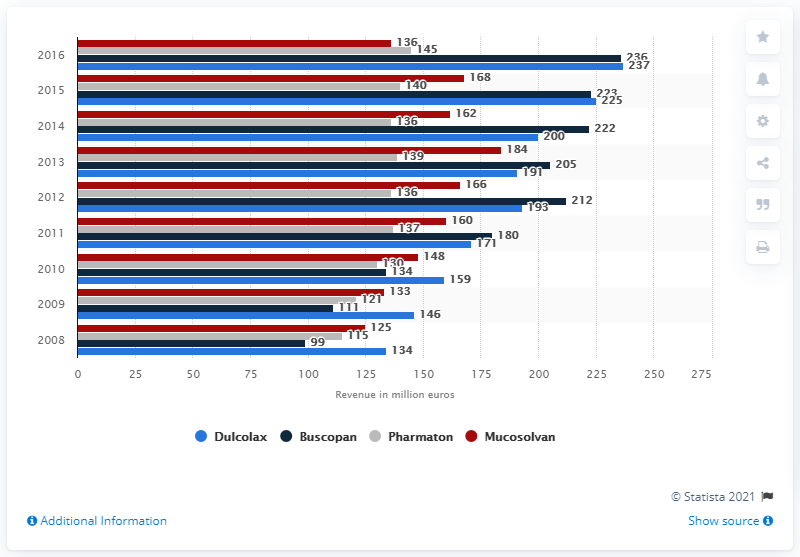Mention a couple of crucial points in this snapshot. In 2008, the net sales of Buscopan were 99... 